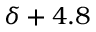<formula> <loc_0><loc_0><loc_500><loc_500>\delta + 4 . 8</formula> 